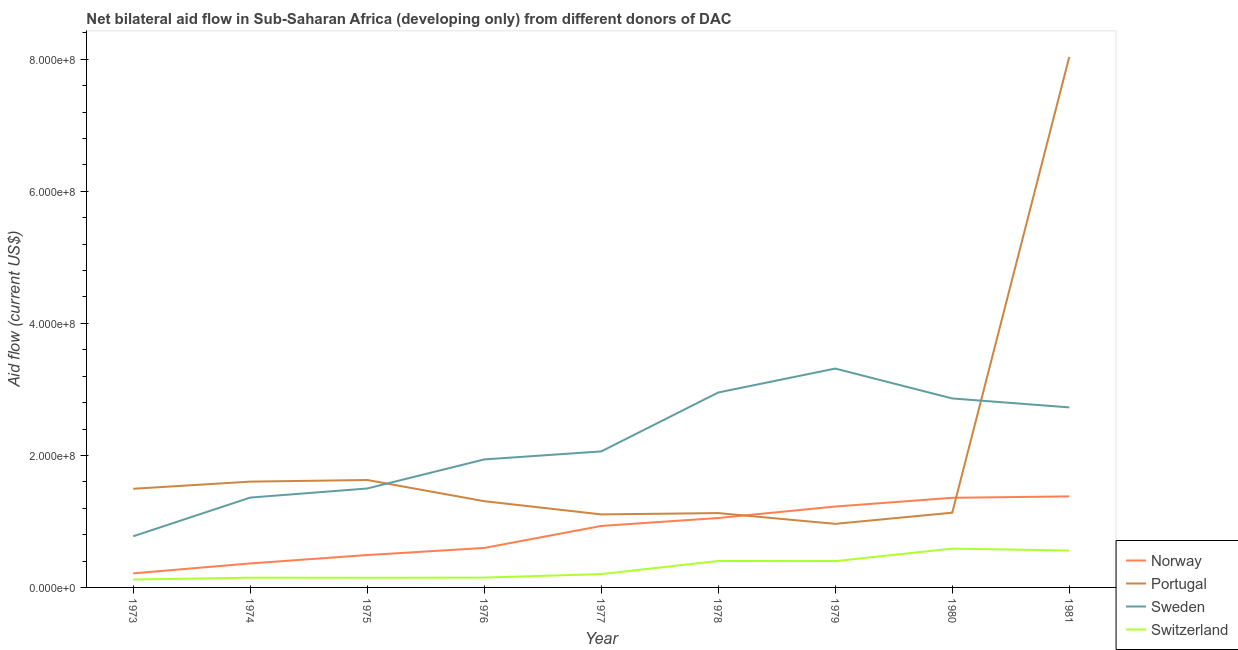Does the line corresponding to amount of aid given by sweden intersect with the line corresponding to amount of aid given by switzerland?
Keep it short and to the point. No. Is the number of lines equal to the number of legend labels?
Provide a short and direct response. Yes. What is the amount of aid given by portugal in 1973?
Provide a short and direct response. 1.49e+08. Across all years, what is the maximum amount of aid given by portugal?
Your answer should be very brief. 8.04e+08. Across all years, what is the minimum amount of aid given by switzerland?
Give a very brief answer. 1.20e+07. In which year was the amount of aid given by sweden maximum?
Make the answer very short. 1979. What is the total amount of aid given by portugal in the graph?
Provide a short and direct response. 1.84e+09. What is the difference between the amount of aid given by norway in 1977 and that in 1981?
Offer a very short reply. -4.48e+07. What is the difference between the amount of aid given by sweden in 1979 and the amount of aid given by switzerland in 1980?
Your answer should be very brief. 2.73e+08. What is the average amount of aid given by portugal per year?
Provide a short and direct response. 2.04e+08. In the year 1977, what is the difference between the amount of aid given by portugal and amount of aid given by norway?
Make the answer very short. 1.75e+07. In how many years, is the amount of aid given by sweden greater than 480000000 US$?
Keep it short and to the point. 0. What is the ratio of the amount of aid given by norway in 1977 to that in 1979?
Your answer should be very brief. 0.76. What is the difference between the highest and the second highest amount of aid given by switzerland?
Keep it short and to the point. 2.96e+06. What is the difference between the highest and the lowest amount of aid given by portugal?
Make the answer very short. 7.07e+08. Is it the case that in every year, the sum of the amount of aid given by portugal and amount of aid given by switzerland is greater than the sum of amount of aid given by norway and amount of aid given by sweden?
Give a very brief answer. No. Does the amount of aid given by norway monotonically increase over the years?
Provide a short and direct response. Yes. How many years are there in the graph?
Your answer should be very brief. 9. Are the values on the major ticks of Y-axis written in scientific E-notation?
Give a very brief answer. Yes. How many legend labels are there?
Your answer should be very brief. 4. What is the title of the graph?
Make the answer very short. Net bilateral aid flow in Sub-Saharan Africa (developing only) from different donors of DAC. What is the label or title of the X-axis?
Your response must be concise. Year. What is the label or title of the Y-axis?
Keep it short and to the point. Aid flow (current US$). What is the Aid flow (current US$) in Norway in 1973?
Your answer should be very brief. 2.13e+07. What is the Aid flow (current US$) in Portugal in 1973?
Provide a succinct answer. 1.49e+08. What is the Aid flow (current US$) in Sweden in 1973?
Offer a very short reply. 7.75e+07. What is the Aid flow (current US$) of Switzerland in 1973?
Provide a succinct answer. 1.20e+07. What is the Aid flow (current US$) of Norway in 1974?
Keep it short and to the point. 3.63e+07. What is the Aid flow (current US$) in Portugal in 1974?
Your answer should be very brief. 1.60e+08. What is the Aid flow (current US$) of Sweden in 1974?
Keep it short and to the point. 1.36e+08. What is the Aid flow (current US$) in Switzerland in 1974?
Your answer should be compact. 1.48e+07. What is the Aid flow (current US$) in Norway in 1975?
Make the answer very short. 4.91e+07. What is the Aid flow (current US$) of Portugal in 1975?
Provide a short and direct response. 1.63e+08. What is the Aid flow (current US$) in Sweden in 1975?
Your answer should be very brief. 1.50e+08. What is the Aid flow (current US$) in Switzerland in 1975?
Your answer should be compact. 1.46e+07. What is the Aid flow (current US$) in Norway in 1976?
Offer a terse response. 5.98e+07. What is the Aid flow (current US$) of Portugal in 1976?
Your answer should be compact. 1.31e+08. What is the Aid flow (current US$) of Sweden in 1976?
Your answer should be compact. 1.94e+08. What is the Aid flow (current US$) of Switzerland in 1976?
Keep it short and to the point. 1.49e+07. What is the Aid flow (current US$) of Norway in 1977?
Provide a short and direct response. 9.32e+07. What is the Aid flow (current US$) of Portugal in 1977?
Your answer should be very brief. 1.11e+08. What is the Aid flow (current US$) in Sweden in 1977?
Provide a short and direct response. 2.06e+08. What is the Aid flow (current US$) of Switzerland in 1977?
Offer a very short reply. 2.02e+07. What is the Aid flow (current US$) in Norway in 1978?
Give a very brief answer. 1.05e+08. What is the Aid flow (current US$) of Portugal in 1978?
Offer a terse response. 1.13e+08. What is the Aid flow (current US$) of Sweden in 1978?
Keep it short and to the point. 2.95e+08. What is the Aid flow (current US$) of Switzerland in 1978?
Your answer should be compact. 4.01e+07. What is the Aid flow (current US$) of Norway in 1979?
Give a very brief answer. 1.23e+08. What is the Aid flow (current US$) in Portugal in 1979?
Keep it short and to the point. 9.63e+07. What is the Aid flow (current US$) in Sweden in 1979?
Provide a succinct answer. 3.32e+08. What is the Aid flow (current US$) of Switzerland in 1979?
Your answer should be very brief. 3.99e+07. What is the Aid flow (current US$) in Norway in 1980?
Offer a very short reply. 1.36e+08. What is the Aid flow (current US$) in Portugal in 1980?
Keep it short and to the point. 1.13e+08. What is the Aid flow (current US$) of Sweden in 1980?
Ensure brevity in your answer.  2.86e+08. What is the Aid flow (current US$) of Switzerland in 1980?
Give a very brief answer. 5.88e+07. What is the Aid flow (current US$) of Norway in 1981?
Ensure brevity in your answer.  1.38e+08. What is the Aid flow (current US$) of Portugal in 1981?
Your answer should be compact. 8.04e+08. What is the Aid flow (current US$) in Sweden in 1981?
Your answer should be very brief. 2.73e+08. What is the Aid flow (current US$) in Switzerland in 1981?
Offer a very short reply. 5.58e+07. Across all years, what is the maximum Aid flow (current US$) of Norway?
Your answer should be compact. 1.38e+08. Across all years, what is the maximum Aid flow (current US$) of Portugal?
Your answer should be compact. 8.04e+08. Across all years, what is the maximum Aid flow (current US$) in Sweden?
Provide a short and direct response. 3.32e+08. Across all years, what is the maximum Aid flow (current US$) in Switzerland?
Your answer should be very brief. 5.88e+07. Across all years, what is the minimum Aid flow (current US$) in Norway?
Ensure brevity in your answer.  2.13e+07. Across all years, what is the minimum Aid flow (current US$) of Portugal?
Ensure brevity in your answer.  9.63e+07. Across all years, what is the minimum Aid flow (current US$) of Sweden?
Your response must be concise. 7.75e+07. Across all years, what is the minimum Aid flow (current US$) of Switzerland?
Your response must be concise. 1.20e+07. What is the total Aid flow (current US$) in Norway in the graph?
Ensure brevity in your answer.  7.61e+08. What is the total Aid flow (current US$) in Portugal in the graph?
Make the answer very short. 1.84e+09. What is the total Aid flow (current US$) in Sweden in the graph?
Provide a short and direct response. 1.95e+09. What is the total Aid flow (current US$) in Switzerland in the graph?
Your answer should be compact. 2.71e+08. What is the difference between the Aid flow (current US$) in Norway in 1973 and that in 1974?
Make the answer very short. -1.50e+07. What is the difference between the Aid flow (current US$) in Portugal in 1973 and that in 1974?
Your response must be concise. -1.08e+07. What is the difference between the Aid flow (current US$) in Sweden in 1973 and that in 1974?
Your response must be concise. -5.86e+07. What is the difference between the Aid flow (current US$) in Switzerland in 1973 and that in 1974?
Provide a short and direct response. -2.82e+06. What is the difference between the Aid flow (current US$) in Norway in 1973 and that in 1975?
Ensure brevity in your answer.  -2.77e+07. What is the difference between the Aid flow (current US$) of Portugal in 1973 and that in 1975?
Your answer should be very brief. -1.33e+07. What is the difference between the Aid flow (current US$) of Sweden in 1973 and that in 1975?
Make the answer very short. -7.24e+07. What is the difference between the Aid flow (current US$) of Switzerland in 1973 and that in 1975?
Offer a very short reply. -2.65e+06. What is the difference between the Aid flow (current US$) in Norway in 1973 and that in 1976?
Ensure brevity in your answer.  -3.85e+07. What is the difference between the Aid flow (current US$) in Portugal in 1973 and that in 1976?
Make the answer very short. 1.88e+07. What is the difference between the Aid flow (current US$) in Sweden in 1973 and that in 1976?
Make the answer very short. -1.16e+08. What is the difference between the Aid flow (current US$) of Switzerland in 1973 and that in 1976?
Give a very brief answer. -2.95e+06. What is the difference between the Aid flow (current US$) of Norway in 1973 and that in 1977?
Make the answer very short. -7.18e+07. What is the difference between the Aid flow (current US$) of Portugal in 1973 and that in 1977?
Your answer should be very brief. 3.88e+07. What is the difference between the Aid flow (current US$) of Sweden in 1973 and that in 1977?
Your response must be concise. -1.29e+08. What is the difference between the Aid flow (current US$) in Switzerland in 1973 and that in 1977?
Give a very brief answer. -8.27e+06. What is the difference between the Aid flow (current US$) in Norway in 1973 and that in 1978?
Your response must be concise. -8.38e+07. What is the difference between the Aid flow (current US$) in Portugal in 1973 and that in 1978?
Ensure brevity in your answer.  3.68e+07. What is the difference between the Aid flow (current US$) in Sweden in 1973 and that in 1978?
Provide a succinct answer. -2.18e+08. What is the difference between the Aid flow (current US$) in Switzerland in 1973 and that in 1978?
Make the answer very short. -2.81e+07. What is the difference between the Aid flow (current US$) of Norway in 1973 and that in 1979?
Your answer should be very brief. -1.01e+08. What is the difference between the Aid flow (current US$) of Portugal in 1973 and that in 1979?
Your response must be concise. 5.31e+07. What is the difference between the Aid flow (current US$) of Sweden in 1973 and that in 1979?
Your answer should be very brief. -2.54e+08. What is the difference between the Aid flow (current US$) of Switzerland in 1973 and that in 1979?
Provide a short and direct response. -2.79e+07. What is the difference between the Aid flow (current US$) of Norway in 1973 and that in 1980?
Keep it short and to the point. -1.14e+08. What is the difference between the Aid flow (current US$) in Portugal in 1973 and that in 1980?
Keep it short and to the point. 3.62e+07. What is the difference between the Aid flow (current US$) of Sweden in 1973 and that in 1980?
Offer a very short reply. -2.09e+08. What is the difference between the Aid flow (current US$) in Switzerland in 1973 and that in 1980?
Your response must be concise. -4.69e+07. What is the difference between the Aid flow (current US$) of Norway in 1973 and that in 1981?
Provide a short and direct response. -1.17e+08. What is the difference between the Aid flow (current US$) in Portugal in 1973 and that in 1981?
Provide a succinct answer. -6.54e+08. What is the difference between the Aid flow (current US$) of Sweden in 1973 and that in 1981?
Give a very brief answer. -1.95e+08. What is the difference between the Aid flow (current US$) of Switzerland in 1973 and that in 1981?
Your response must be concise. -4.39e+07. What is the difference between the Aid flow (current US$) in Norway in 1974 and that in 1975?
Make the answer very short. -1.27e+07. What is the difference between the Aid flow (current US$) of Portugal in 1974 and that in 1975?
Give a very brief answer. -2.45e+06. What is the difference between the Aid flow (current US$) in Sweden in 1974 and that in 1975?
Your answer should be compact. -1.38e+07. What is the difference between the Aid flow (current US$) in Norway in 1974 and that in 1976?
Provide a succinct answer. -2.35e+07. What is the difference between the Aid flow (current US$) of Portugal in 1974 and that in 1976?
Your answer should be very brief. 2.96e+07. What is the difference between the Aid flow (current US$) in Sweden in 1974 and that in 1976?
Provide a succinct answer. -5.78e+07. What is the difference between the Aid flow (current US$) of Switzerland in 1974 and that in 1976?
Your answer should be compact. -1.30e+05. What is the difference between the Aid flow (current US$) of Norway in 1974 and that in 1977?
Provide a short and direct response. -5.68e+07. What is the difference between the Aid flow (current US$) of Portugal in 1974 and that in 1977?
Offer a terse response. 4.97e+07. What is the difference between the Aid flow (current US$) in Sweden in 1974 and that in 1977?
Ensure brevity in your answer.  -7.00e+07. What is the difference between the Aid flow (current US$) in Switzerland in 1974 and that in 1977?
Provide a short and direct response. -5.45e+06. What is the difference between the Aid flow (current US$) in Norway in 1974 and that in 1978?
Give a very brief answer. -6.88e+07. What is the difference between the Aid flow (current US$) in Portugal in 1974 and that in 1978?
Offer a terse response. 4.77e+07. What is the difference between the Aid flow (current US$) in Sweden in 1974 and that in 1978?
Ensure brevity in your answer.  -1.59e+08. What is the difference between the Aid flow (current US$) in Switzerland in 1974 and that in 1978?
Make the answer very short. -2.53e+07. What is the difference between the Aid flow (current US$) of Norway in 1974 and that in 1979?
Make the answer very short. -8.62e+07. What is the difference between the Aid flow (current US$) in Portugal in 1974 and that in 1979?
Your answer should be compact. 6.40e+07. What is the difference between the Aid flow (current US$) of Sweden in 1974 and that in 1979?
Give a very brief answer. -1.95e+08. What is the difference between the Aid flow (current US$) of Switzerland in 1974 and that in 1979?
Your answer should be very brief. -2.51e+07. What is the difference between the Aid flow (current US$) of Norway in 1974 and that in 1980?
Provide a short and direct response. -9.94e+07. What is the difference between the Aid flow (current US$) in Portugal in 1974 and that in 1980?
Ensure brevity in your answer.  4.71e+07. What is the difference between the Aid flow (current US$) in Sweden in 1974 and that in 1980?
Offer a terse response. -1.50e+08. What is the difference between the Aid flow (current US$) of Switzerland in 1974 and that in 1980?
Provide a succinct answer. -4.40e+07. What is the difference between the Aid flow (current US$) in Norway in 1974 and that in 1981?
Offer a terse response. -1.02e+08. What is the difference between the Aid flow (current US$) of Portugal in 1974 and that in 1981?
Ensure brevity in your answer.  -6.43e+08. What is the difference between the Aid flow (current US$) of Sweden in 1974 and that in 1981?
Your response must be concise. -1.37e+08. What is the difference between the Aid flow (current US$) in Switzerland in 1974 and that in 1981?
Provide a succinct answer. -4.11e+07. What is the difference between the Aid flow (current US$) in Norway in 1975 and that in 1976?
Your answer should be very brief. -1.07e+07. What is the difference between the Aid flow (current US$) in Portugal in 1975 and that in 1976?
Offer a very short reply. 3.21e+07. What is the difference between the Aid flow (current US$) of Sweden in 1975 and that in 1976?
Keep it short and to the point. -4.40e+07. What is the difference between the Aid flow (current US$) of Switzerland in 1975 and that in 1976?
Your answer should be very brief. -3.00e+05. What is the difference between the Aid flow (current US$) of Norway in 1975 and that in 1977?
Provide a short and direct response. -4.41e+07. What is the difference between the Aid flow (current US$) in Portugal in 1975 and that in 1977?
Make the answer very short. 5.21e+07. What is the difference between the Aid flow (current US$) of Sweden in 1975 and that in 1977?
Your response must be concise. -5.62e+07. What is the difference between the Aid flow (current US$) of Switzerland in 1975 and that in 1977?
Offer a very short reply. -5.62e+06. What is the difference between the Aid flow (current US$) in Norway in 1975 and that in 1978?
Provide a succinct answer. -5.61e+07. What is the difference between the Aid flow (current US$) in Portugal in 1975 and that in 1978?
Make the answer very short. 5.01e+07. What is the difference between the Aid flow (current US$) of Sweden in 1975 and that in 1978?
Ensure brevity in your answer.  -1.45e+08. What is the difference between the Aid flow (current US$) in Switzerland in 1975 and that in 1978?
Provide a succinct answer. -2.55e+07. What is the difference between the Aid flow (current US$) of Norway in 1975 and that in 1979?
Your answer should be very brief. -7.35e+07. What is the difference between the Aid flow (current US$) in Portugal in 1975 and that in 1979?
Offer a terse response. 6.64e+07. What is the difference between the Aid flow (current US$) of Sweden in 1975 and that in 1979?
Your answer should be very brief. -1.82e+08. What is the difference between the Aid flow (current US$) in Switzerland in 1975 and that in 1979?
Ensure brevity in your answer.  -2.53e+07. What is the difference between the Aid flow (current US$) in Norway in 1975 and that in 1980?
Your answer should be very brief. -8.67e+07. What is the difference between the Aid flow (current US$) in Portugal in 1975 and that in 1980?
Ensure brevity in your answer.  4.95e+07. What is the difference between the Aid flow (current US$) of Sweden in 1975 and that in 1980?
Provide a succinct answer. -1.36e+08. What is the difference between the Aid flow (current US$) in Switzerland in 1975 and that in 1980?
Make the answer very short. -4.42e+07. What is the difference between the Aid flow (current US$) of Norway in 1975 and that in 1981?
Your answer should be very brief. -8.89e+07. What is the difference between the Aid flow (current US$) in Portugal in 1975 and that in 1981?
Provide a succinct answer. -6.41e+08. What is the difference between the Aid flow (current US$) of Sweden in 1975 and that in 1981?
Ensure brevity in your answer.  -1.23e+08. What is the difference between the Aid flow (current US$) in Switzerland in 1975 and that in 1981?
Your answer should be compact. -4.12e+07. What is the difference between the Aid flow (current US$) of Norway in 1976 and that in 1977?
Give a very brief answer. -3.34e+07. What is the difference between the Aid flow (current US$) in Portugal in 1976 and that in 1977?
Offer a terse response. 2.00e+07. What is the difference between the Aid flow (current US$) in Sweden in 1976 and that in 1977?
Ensure brevity in your answer.  -1.22e+07. What is the difference between the Aid flow (current US$) in Switzerland in 1976 and that in 1977?
Offer a terse response. -5.32e+06. What is the difference between the Aid flow (current US$) in Norway in 1976 and that in 1978?
Your answer should be compact. -4.54e+07. What is the difference between the Aid flow (current US$) in Portugal in 1976 and that in 1978?
Ensure brevity in your answer.  1.80e+07. What is the difference between the Aid flow (current US$) of Sweden in 1976 and that in 1978?
Offer a terse response. -1.01e+08. What is the difference between the Aid flow (current US$) in Switzerland in 1976 and that in 1978?
Provide a succinct answer. -2.52e+07. What is the difference between the Aid flow (current US$) of Norway in 1976 and that in 1979?
Provide a short and direct response. -6.27e+07. What is the difference between the Aid flow (current US$) of Portugal in 1976 and that in 1979?
Give a very brief answer. 3.43e+07. What is the difference between the Aid flow (current US$) in Sweden in 1976 and that in 1979?
Provide a succinct answer. -1.38e+08. What is the difference between the Aid flow (current US$) in Switzerland in 1976 and that in 1979?
Make the answer very short. -2.50e+07. What is the difference between the Aid flow (current US$) in Norway in 1976 and that in 1980?
Ensure brevity in your answer.  -7.60e+07. What is the difference between the Aid flow (current US$) of Portugal in 1976 and that in 1980?
Ensure brevity in your answer.  1.74e+07. What is the difference between the Aid flow (current US$) of Sweden in 1976 and that in 1980?
Offer a terse response. -9.24e+07. What is the difference between the Aid flow (current US$) of Switzerland in 1976 and that in 1980?
Make the answer very short. -4.39e+07. What is the difference between the Aid flow (current US$) in Norway in 1976 and that in 1981?
Provide a succinct answer. -7.81e+07. What is the difference between the Aid flow (current US$) of Portugal in 1976 and that in 1981?
Offer a terse response. -6.73e+08. What is the difference between the Aid flow (current US$) of Sweden in 1976 and that in 1981?
Keep it short and to the point. -7.88e+07. What is the difference between the Aid flow (current US$) of Switzerland in 1976 and that in 1981?
Provide a short and direct response. -4.10e+07. What is the difference between the Aid flow (current US$) in Norway in 1977 and that in 1978?
Your answer should be compact. -1.20e+07. What is the difference between the Aid flow (current US$) in Portugal in 1977 and that in 1978?
Your answer should be compact. -2.00e+06. What is the difference between the Aid flow (current US$) in Sweden in 1977 and that in 1978?
Your answer should be very brief. -8.92e+07. What is the difference between the Aid flow (current US$) of Switzerland in 1977 and that in 1978?
Provide a short and direct response. -1.98e+07. What is the difference between the Aid flow (current US$) in Norway in 1977 and that in 1979?
Offer a very short reply. -2.94e+07. What is the difference between the Aid flow (current US$) of Portugal in 1977 and that in 1979?
Make the answer very short. 1.43e+07. What is the difference between the Aid flow (current US$) in Sweden in 1977 and that in 1979?
Your answer should be compact. -1.26e+08. What is the difference between the Aid flow (current US$) in Switzerland in 1977 and that in 1979?
Provide a short and direct response. -1.97e+07. What is the difference between the Aid flow (current US$) of Norway in 1977 and that in 1980?
Your answer should be very brief. -4.26e+07. What is the difference between the Aid flow (current US$) in Portugal in 1977 and that in 1980?
Make the answer very short. -2.60e+06. What is the difference between the Aid flow (current US$) of Sweden in 1977 and that in 1980?
Give a very brief answer. -8.02e+07. What is the difference between the Aid flow (current US$) in Switzerland in 1977 and that in 1980?
Provide a short and direct response. -3.86e+07. What is the difference between the Aid flow (current US$) of Norway in 1977 and that in 1981?
Make the answer very short. -4.48e+07. What is the difference between the Aid flow (current US$) of Portugal in 1977 and that in 1981?
Keep it short and to the point. -6.93e+08. What is the difference between the Aid flow (current US$) in Sweden in 1977 and that in 1981?
Make the answer very short. -6.67e+07. What is the difference between the Aid flow (current US$) of Switzerland in 1977 and that in 1981?
Provide a succinct answer. -3.56e+07. What is the difference between the Aid flow (current US$) of Norway in 1978 and that in 1979?
Offer a terse response. -1.74e+07. What is the difference between the Aid flow (current US$) of Portugal in 1978 and that in 1979?
Give a very brief answer. 1.63e+07. What is the difference between the Aid flow (current US$) in Sweden in 1978 and that in 1979?
Keep it short and to the point. -3.62e+07. What is the difference between the Aid flow (current US$) of Switzerland in 1978 and that in 1979?
Provide a succinct answer. 1.90e+05. What is the difference between the Aid flow (current US$) of Norway in 1978 and that in 1980?
Make the answer very short. -3.06e+07. What is the difference between the Aid flow (current US$) in Portugal in 1978 and that in 1980?
Your answer should be compact. -6.00e+05. What is the difference between the Aid flow (current US$) of Sweden in 1978 and that in 1980?
Give a very brief answer. 9.03e+06. What is the difference between the Aid flow (current US$) of Switzerland in 1978 and that in 1980?
Your response must be concise. -1.87e+07. What is the difference between the Aid flow (current US$) of Norway in 1978 and that in 1981?
Ensure brevity in your answer.  -3.28e+07. What is the difference between the Aid flow (current US$) of Portugal in 1978 and that in 1981?
Give a very brief answer. -6.91e+08. What is the difference between the Aid flow (current US$) of Sweden in 1978 and that in 1981?
Your answer should be compact. 2.26e+07. What is the difference between the Aid flow (current US$) in Switzerland in 1978 and that in 1981?
Provide a short and direct response. -1.58e+07. What is the difference between the Aid flow (current US$) of Norway in 1979 and that in 1980?
Offer a very short reply. -1.32e+07. What is the difference between the Aid flow (current US$) of Portugal in 1979 and that in 1980?
Keep it short and to the point. -1.69e+07. What is the difference between the Aid flow (current US$) of Sweden in 1979 and that in 1980?
Your response must be concise. 4.53e+07. What is the difference between the Aid flow (current US$) in Switzerland in 1979 and that in 1980?
Offer a very short reply. -1.89e+07. What is the difference between the Aid flow (current US$) of Norway in 1979 and that in 1981?
Provide a short and direct response. -1.54e+07. What is the difference between the Aid flow (current US$) in Portugal in 1979 and that in 1981?
Your answer should be compact. -7.07e+08. What is the difference between the Aid flow (current US$) in Sweden in 1979 and that in 1981?
Offer a very short reply. 5.88e+07. What is the difference between the Aid flow (current US$) in Switzerland in 1979 and that in 1981?
Provide a succinct answer. -1.60e+07. What is the difference between the Aid flow (current US$) of Norway in 1980 and that in 1981?
Keep it short and to the point. -2.14e+06. What is the difference between the Aid flow (current US$) in Portugal in 1980 and that in 1981?
Offer a terse response. -6.90e+08. What is the difference between the Aid flow (current US$) in Sweden in 1980 and that in 1981?
Make the answer very short. 1.35e+07. What is the difference between the Aid flow (current US$) in Switzerland in 1980 and that in 1981?
Your answer should be very brief. 2.96e+06. What is the difference between the Aid flow (current US$) of Norway in 1973 and the Aid flow (current US$) of Portugal in 1974?
Provide a succinct answer. -1.39e+08. What is the difference between the Aid flow (current US$) of Norway in 1973 and the Aid flow (current US$) of Sweden in 1974?
Your answer should be very brief. -1.15e+08. What is the difference between the Aid flow (current US$) in Norway in 1973 and the Aid flow (current US$) in Switzerland in 1974?
Offer a terse response. 6.55e+06. What is the difference between the Aid flow (current US$) of Portugal in 1973 and the Aid flow (current US$) of Sweden in 1974?
Provide a short and direct response. 1.34e+07. What is the difference between the Aid flow (current US$) of Portugal in 1973 and the Aid flow (current US$) of Switzerland in 1974?
Give a very brief answer. 1.35e+08. What is the difference between the Aid flow (current US$) in Sweden in 1973 and the Aid flow (current US$) in Switzerland in 1974?
Keep it short and to the point. 6.27e+07. What is the difference between the Aid flow (current US$) of Norway in 1973 and the Aid flow (current US$) of Portugal in 1975?
Provide a succinct answer. -1.41e+08. What is the difference between the Aid flow (current US$) in Norway in 1973 and the Aid flow (current US$) in Sweden in 1975?
Keep it short and to the point. -1.29e+08. What is the difference between the Aid flow (current US$) of Norway in 1973 and the Aid flow (current US$) of Switzerland in 1975?
Give a very brief answer. 6.72e+06. What is the difference between the Aid flow (current US$) in Portugal in 1973 and the Aid flow (current US$) in Sweden in 1975?
Your answer should be very brief. -4.30e+05. What is the difference between the Aid flow (current US$) in Portugal in 1973 and the Aid flow (current US$) in Switzerland in 1975?
Give a very brief answer. 1.35e+08. What is the difference between the Aid flow (current US$) in Sweden in 1973 and the Aid flow (current US$) in Switzerland in 1975?
Offer a very short reply. 6.29e+07. What is the difference between the Aid flow (current US$) of Norway in 1973 and the Aid flow (current US$) of Portugal in 1976?
Keep it short and to the point. -1.09e+08. What is the difference between the Aid flow (current US$) of Norway in 1973 and the Aid flow (current US$) of Sweden in 1976?
Make the answer very short. -1.73e+08. What is the difference between the Aid flow (current US$) of Norway in 1973 and the Aid flow (current US$) of Switzerland in 1976?
Offer a very short reply. 6.42e+06. What is the difference between the Aid flow (current US$) of Portugal in 1973 and the Aid flow (current US$) of Sweden in 1976?
Make the answer very short. -4.45e+07. What is the difference between the Aid flow (current US$) in Portugal in 1973 and the Aid flow (current US$) in Switzerland in 1976?
Offer a terse response. 1.35e+08. What is the difference between the Aid flow (current US$) of Sweden in 1973 and the Aid flow (current US$) of Switzerland in 1976?
Your answer should be compact. 6.26e+07. What is the difference between the Aid flow (current US$) in Norway in 1973 and the Aid flow (current US$) in Portugal in 1977?
Your answer should be very brief. -8.93e+07. What is the difference between the Aid flow (current US$) in Norway in 1973 and the Aid flow (current US$) in Sweden in 1977?
Ensure brevity in your answer.  -1.85e+08. What is the difference between the Aid flow (current US$) in Norway in 1973 and the Aid flow (current US$) in Switzerland in 1977?
Provide a short and direct response. 1.10e+06. What is the difference between the Aid flow (current US$) of Portugal in 1973 and the Aid flow (current US$) of Sweden in 1977?
Make the answer very short. -5.66e+07. What is the difference between the Aid flow (current US$) of Portugal in 1973 and the Aid flow (current US$) of Switzerland in 1977?
Your response must be concise. 1.29e+08. What is the difference between the Aid flow (current US$) of Sweden in 1973 and the Aid flow (current US$) of Switzerland in 1977?
Your response must be concise. 5.73e+07. What is the difference between the Aid flow (current US$) in Norway in 1973 and the Aid flow (current US$) in Portugal in 1978?
Your answer should be very brief. -9.13e+07. What is the difference between the Aid flow (current US$) of Norway in 1973 and the Aid flow (current US$) of Sweden in 1978?
Offer a very short reply. -2.74e+08. What is the difference between the Aid flow (current US$) in Norway in 1973 and the Aid flow (current US$) in Switzerland in 1978?
Keep it short and to the point. -1.88e+07. What is the difference between the Aid flow (current US$) in Portugal in 1973 and the Aid flow (current US$) in Sweden in 1978?
Your response must be concise. -1.46e+08. What is the difference between the Aid flow (current US$) in Portugal in 1973 and the Aid flow (current US$) in Switzerland in 1978?
Your answer should be very brief. 1.09e+08. What is the difference between the Aid flow (current US$) of Sweden in 1973 and the Aid flow (current US$) of Switzerland in 1978?
Keep it short and to the point. 3.74e+07. What is the difference between the Aid flow (current US$) of Norway in 1973 and the Aid flow (current US$) of Portugal in 1979?
Give a very brief answer. -7.50e+07. What is the difference between the Aid flow (current US$) of Norway in 1973 and the Aid flow (current US$) of Sweden in 1979?
Offer a very short reply. -3.10e+08. What is the difference between the Aid flow (current US$) of Norway in 1973 and the Aid flow (current US$) of Switzerland in 1979?
Keep it short and to the point. -1.86e+07. What is the difference between the Aid flow (current US$) in Portugal in 1973 and the Aid flow (current US$) in Sweden in 1979?
Offer a very short reply. -1.82e+08. What is the difference between the Aid flow (current US$) in Portugal in 1973 and the Aid flow (current US$) in Switzerland in 1979?
Ensure brevity in your answer.  1.10e+08. What is the difference between the Aid flow (current US$) in Sweden in 1973 and the Aid flow (current US$) in Switzerland in 1979?
Offer a terse response. 3.76e+07. What is the difference between the Aid flow (current US$) in Norway in 1973 and the Aid flow (current US$) in Portugal in 1980?
Offer a terse response. -9.19e+07. What is the difference between the Aid flow (current US$) in Norway in 1973 and the Aid flow (current US$) in Sweden in 1980?
Your answer should be compact. -2.65e+08. What is the difference between the Aid flow (current US$) of Norway in 1973 and the Aid flow (current US$) of Switzerland in 1980?
Ensure brevity in your answer.  -3.75e+07. What is the difference between the Aid flow (current US$) of Portugal in 1973 and the Aid flow (current US$) of Sweden in 1980?
Offer a terse response. -1.37e+08. What is the difference between the Aid flow (current US$) in Portugal in 1973 and the Aid flow (current US$) in Switzerland in 1980?
Keep it short and to the point. 9.06e+07. What is the difference between the Aid flow (current US$) in Sweden in 1973 and the Aid flow (current US$) in Switzerland in 1980?
Offer a very short reply. 1.87e+07. What is the difference between the Aid flow (current US$) of Norway in 1973 and the Aid flow (current US$) of Portugal in 1981?
Your answer should be very brief. -7.82e+08. What is the difference between the Aid flow (current US$) in Norway in 1973 and the Aid flow (current US$) in Sweden in 1981?
Ensure brevity in your answer.  -2.51e+08. What is the difference between the Aid flow (current US$) in Norway in 1973 and the Aid flow (current US$) in Switzerland in 1981?
Keep it short and to the point. -3.45e+07. What is the difference between the Aid flow (current US$) in Portugal in 1973 and the Aid flow (current US$) in Sweden in 1981?
Your answer should be compact. -1.23e+08. What is the difference between the Aid flow (current US$) of Portugal in 1973 and the Aid flow (current US$) of Switzerland in 1981?
Keep it short and to the point. 9.36e+07. What is the difference between the Aid flow (current US$) in Sweden in 1973 and the Aid flow (current US$) in Switzerland in 1981?
Make the answer very short. 2.16e+07. What is the difference between the Aid flow (current US$) of Norway in 1974 and the Aid flow (current US$) of Portugal in 1975?
Give a very brief answer. -1.26e+08. What is the difference between the Aid flow (current US$) in Norway in 1974 and the Aid flow (current US$) in Sweden in 1975?
Offer a terse response. -1.14e+08. What is the difference between the Aid flow (current US$) of Norway in 1974 and the Aid flow (current US$) of Switzerland in 1975?
Offer a terse response. 2.17e+07. What is the difference between the Aid flow (current US$) in Portugal in 1974 and the Aid flow (current US$) in Sweden in 1975?
Make the answer very short. 1.04e+07. What is the difference between the Aid flow (current US$) of Portugal in 1974 and the Aid flow (current US$) of Switzerland in 1975?
Your answer should be very brief. 1.46e+08. What is the difference between the Aid flow (current US$) in Sweden in 1974 and the Aid flow (current US$) in Switzerland in 1975?
Your answer should be very brief. 1.22e+08. What is the difference between the Aid flow (current US$) in Norway in 1974 and the Aid flow (current US$) in Portugal in 1976?
Keep it short and to the point. -9.43e+07. What is the difference between the Aid flow (current US$) of Norway in 1974 and the Aid flow (current US$) of Sweden in 1976?
Your answer should be compact. -1.58e+08. What is the difference between the Aid flow (current US$) of Norway in 1974 and the Aid flow (current US$) of Switzerland in 1976?
Make the answer very short. 2.14e+07. What is the difference between the Aid flow (current US$) in Portugal in 1974 and the Aid flow (current US$) in Sweden in 1976?
Your answer should be compact. -3.36e+07. What is the difference between the Aid flow (current US$) of Portugal in 1974 and the Aid flow (current US$) of Switzerland in 1976?
Your answer should be compact. 1.45e+08. What is the difference between the Aid flow (current US$) of Sweden in 1974 and the Aid flow (current US$) of Switzerland in 1976?
Ensure brevity in your answer.  1.21e+08. What is the difference between the Aid flow (current US$) of Norway in 1974 and the Aid flow (current US$) of Portugal in 1977?
Make the answer very short. -7.43e+07. What is the difference between the Aid flow (current US$) of Norway in 1974 and the Aid flow (current US$) of Sweden in 1977?
Give a very brief answer. -1.70e+08. What is the difference between the Aid flow (current US$) of Norway in 1974 and the Aid flow (current US$) of Switzerland in 1977?
Your answer should be compact. 1.61e+07. What is the difference between the Aid flow (current US$) in Portugal in 1974 and the Aid flow (current US$) in Sweden in 1977?
Provide a short and direct response. -4.58e+07. What is the difference between the Aid flow (current US$) in Portugal in 1974 and the Aid flow (current US$) in Switzerland in 1977?
Provide a short and direct response. 1.40e+08. What is the difference between the Aid flow (current US$) in Sweden in 1974 and the Aid flow (current US$) in Switzerland in 1977?
Provide a succinct answer. 1.16e+08. What is the difference between the Aid flow (current US$) of Norway in 1974 and the Aid flow (current US$) of Portugal in 1978?
Keep it short and to the point. -7.63e+07. What is the difference between the Aid flow (current US$) of Norway in 1974 and the Aid flow (current US$) of Sweden in 1978?
Provide a succinct answer. -2.59e+08. What is the difference between the Aid flow (current US$) in Norway in 1974 and the Aid flow (current US$) in Switzerland in 1978?
Make the answer very short. -3.73e+06. What is the difference between the Aid flow (current US$) of Portugal in 1974 and the Aid flow (current US$) of Sweden in 1978?
Give a very brief answer. -1.35e+08. What is the difference between the Aid flow (current US$) of Portugal in 1974 and the Aid flow (current US$) of Switzerland in 1978?
Keep it short and to the point. 1.20e+08. What is the difference between the Aid flow (current US$) of Sweden in 1974 and the Aid flow (current US$) of Switzerland in 1978?
Keep it short and to the point. 9.60e+07. What is the difference between the Aid flow (current US$) of Norway in 1974 and the Aid flow (current US$) of Portugal in 1979?
Offer a very short reply. -6.00e+07. What is the difference between the Aid flow (current US$) in Norway in 1974 and the Aid flow (current US$) in Sweden in 1979?
Your answer should be compact. -2.95e+08. What is the difference between the Aid flow (current US$) in Norway in 1974 and the Aid flow (current US$) in Switzerland in 1979?
Offer a terse response. -3.54e+06. What is the difference between the Aid flow (current US$) of Portugal in 1974 and the Aid flow (current US$) of Sweden in 1979?
Provide a short and direct response. -1.71e+08. What is the difference between the Aid flow (current US$) of Portugal in 1974 and the Aid flow (current US$) of Switzerland in 1979?
Give a very brief answer. 1.20e+08. What is the difference between the Aid flow (current US$) in Sweden in 1974 and the Aid flow (current US$) in Switzerland in 1979?
Your answer should be very brief. 9.62e+07. What is the difference between the Aid flow (current US$) of Norway in 1974 and the Aid flow (current US$) of Portugal in 1980?
Make the answer very short. -7.69e+07. What is the difference between the Aid flow (current US$) in Norway in 1974 and the Aid flow (current US$) in Sweden in 1980?
Your answer should be compact. -2.50e+08. What is the difference between the Aid flow (current US$) in Norway in 1974 and the Aid flow (current US$) in Switzerland in 1980?
Offer a terse response. -2.25e+07. What is the difference between the Aid flow (current US$) of Portugal in 1974 and the Aid flow (current US$) of Sweden in 1980?
Offer a very short reply. -1.26e+08. What is the difference between the Aid flow (current US$) in Portugal in 1974 and the Aid flow (current US$) in Switzerland in 1980?
Offer a very short reply. 1.01e+08. What is the difference between the Aid flow (current US$) of Sweden in 1974 and the Aid flow (current US$) of Switzerland in 1980?
Your answer should be compact. 7.73e+07. What is the difference between the Aid flow (current US$) in Norway in 1974 and the Aid flow (current US$) in Portugal in 1981?
Your answer should be compact. -7.67e+08. What is the difference between the Aid flow (current US$) in Norway in 1974 and the Aid flow (current US$) in Sweden in 1981?
Offer a very short reply. -2.36e+08. What is the difference between the Aid flow (current US$) in Norway in 1974 and the Aid flow (current US$) in Switzerland in 1981?
Give a very brief answer. -1.95e+07. What is the difference between the Aid flow (current US$) of Portugal in 1974 and the Aid flow (current US$) of Sweden in 1981?
Provide a succinct answer. -1.12e+08. What is the difference between the Aid flow (current US$) in Portugal in 1974 and the Aid flow (current US$) in Switzerland in 1981?
Your response must be concise. 1.04e+08. What is the difference between the Aid flow (current US$) of Sweden in 1974 and the Aid flow (current US$) of Switzerland in 1981?
Your answer should be compact. 8.02e+07. What is the difference between the Aid flow (current US$) of Norway in 1975 and the Aid flow (current US$) of Portugal in 1976?
Keep it short and to the point. -8.16e+07. What is the difference between the Aid flow (current US$) of Norway in 1975 and the Aid flow (current US$) of Sweden in 1976?
Give a very brief answer. -1.45e+08. What is the difference between the Aid flow (current US$) of Norway in 1975 and the Aid flow (current US$) of Switzerland in 1976?
Your answer should be compact. 3.42e+07. What is the difference between the Aid flow (current US$) in Portugal in 1975 and the Aid flow (current US$) in Sweden in 1976?
Give a very brief answer. -3.12e+07. What is the difference between the Aid flow (current US$) in Portugal in 1975 and the Aid flow (current US$) in Switzerland in 1976?
Your answer should be compact. 1.48e+08. What is the difference between the Aid flow (current US$) of Sweden in 1975 and the Aid flow (current US$) of Switzerland in 1976?
Ensure brevity in your answer.  1.35e+08. What is the difference between the Aid flow (current US$) of Norway in 1975 and the Aid flow (current US$) of Portugal in 1977?
Your response must be concise. -6.16e+07. What is the difference between the Aid flow (current US$) in Norway in 1975 and the Aid flow (current US$) in Sweden in 1977?
Keep it short and to the point. -1.57e+08. What is the difference between the Aid flow (current US$) in Norway in 1975 and the Aid flow (current US$) in Switzerland in 1977?
Your answer should be very brief. 2.88e+07. What is the difference between the Aid flow (current US$) in Portugal in 1975 and the Aid flow (current US$) in Sweden in 1977?
Keep it short and to the point. -4.33e+07. What is the difference between the Aid flow (current US$) of Portugal in 1975 and the Aid flow (current US$) of Switzerland in 1977?
Your answer should be very brief. 1.43e+08. What is the difference between the Aid flow (current US$) in Sweden in 1975 and the Aid flow (current US$) in Switzerland in 1977?
Provide a short and direct response. 1.30e+08. What is the difference between the Aid flow (current US$) of Norway in 1975 and the Aid flow (current US$) of Portugal in 1978?
Your answer should be compact. -6.36e+07. What is the difference between the Aid flow (current US$) in Norway in 1975 and the Aid flow (current US$) in Sweden in 1978?
Provide a short and direct response. -2.46e+08. What is the difference between the Aid flow (current US$) of Norway in 1975 and the Aid flow (current US$) of Switzerland in 1978?
Your response must be concise. 8.99e+06. What is the difference between the Aid flow (current US$) in Portugal in 1975 and the Aid flow (current US$) in Sweden in 1978?
Your answer should be compact. -1.33e+08. What is the difference between the Aid flow (current US$) of Portugal in 1975 and the Aid flow (current US$) of Switzerland in 1978?
Offer a terse response. 1.23e+08. What is the difference between the Aid flow (current US$) of Sweden in 1975 and the Aid flow (current US$) of Switzerland in 1978?
Give a very brief answer. 1.10e+08. What is the difference between the Aid flow (current US$) in Norway in 1975 and the Aid flow (current US$) in Portugal in 1979?
Give a very brief answer. -4.72e+07. What is the difference between the Aid flow (current US$) in Norway in 1975 and the Aid flow (current US$) in Sweden in 1979?
Your answer should be compact. -2.82e+08. What is the difference between the Aid flow (current US$) of Norway in 1975 and the Aid flow (current US$) of Switzerland in 1979?
Make the answer very short. 9.18e+06. What is the difference between the Aid flow (current US$) of Portugal in 1975 and the Aid flow (current US$) of Sweden in 1979?
Offer a terse response. -1.69e+08. What is the difference between the Aid flow (current US$) of Portugal in 1975 and the Aid flow (current US$) of Switzerland in 1979?
Make the answer very short. 1.23e+08. What is the difference between the Aid flow (current US$) of Sweden in 1975 and the Aid flow (current US$) of Switzerland in 1979?
Ensure brevity in your answer.  1.10e+08. What is the difference between the Aid flow (current US$) in Norway in 1975 and the Aid flow (current US$) in Portugal in 1980?
Your answer should be very brief. -6.42e+07. What is the difference between the Aid flow (current US$) in Norway in 1975 and the Aid flow (current US$) in Sweden in 1980?
Provide a succinct answer. -2.37e+08. What is the difference between the Aid flow (current US$) of Norway in 1975 and the Aid flow (current US$) of Switzerland in 1980?
Give a very brief answer. -9.75e+06. What is the difference between the Aid flow (current US$) of Portugal in 1975 and the Aid flow (current US$) of Sweden in 1980?
Your response must be concise. -1.24e+08. What is the difference between the Aid flow (current US$) in Portugal in 1975 and the Aid flow (current US$) in Switzerland in 1980?
Your answer should be very brief. 1.04e+08. What is the difference between the Aid flow (current US$) of Sweden in 1975 and the Aid flow (current US$) of Switzerland in 1980?
Provide a short and direct response. 9.11e+07. What is the difference between the Aid flow (current US$) in Norway in 1975 and the Aid flow (current US$) in Portugal in 1981?
Your answer should be compact. -7.55e+08. What is the difference between the Aid flow (current US$) in Norway in 1975 and the Aid flow (current US$) in Sweden in 1981?
Ensure brevity in your answer.  -2.24e+08. What is the difference between the Aid flow (current US$) in Norway in 1975 and the Aid flow (current US$) in Switzerland in 1981?
Your answer should be very brief. -6.79e+06. What is the difference between the Aid flow (current US$) in Portugal in 1975 and the Aid flow (current US$) in Sweden in 1981?
Ensure brevity in your answer.  -1.10e+08. What is the difference between the Aid flow (current US$) of Portugal in 1975 and the Aid flow (current US$) of Switzerland in 1981?
Ensure brevity in your answer.  1.07e+08. What is the difference between the Aid flow (current US$) in Sweden in 1975 and the Aid flow (current US$) in Switzerland in 1981?
Offer a terse response. 9.40e+07. What is the difference between the Aid flow (current US$) of Norway in 1976 and the Aid flow (current US$) of Portugal in 1977?
Ensure brevity in your answer.  -5.08e+07. What is the difference between the Aid flow (current US$) of Norway in 1976 and the Aid flow (current US$) of Sweden in 1977?
Provide a succinct answer. -1.46e+08. What is the difference between the Aid flow (current US$) in Norway in 1976 and the Aid flow (current US$) in Switzerland in 1977?
Keep it short and to the point. 3.96e+07. What is the difference between the Aid flow (current US$) of Portugal in 1976 and the Aid flow (current US$) of Sweden in 1977?
Offer a very short reply. -7.54e+07. What is the difference between the Aid flow (current US$) of Portugal in 1976 and the Aid flow (current US$) of Switzerland in 1977?
Make the answer very short. 1.10e+08. What is the difference between the Aid flow (current US$) of Sweden in 1976 and the Aid flow (current US$) of Switzerland in 1977?
Provide a short and direct response. 1.74e+08. What is the difference between the Aid flow (current US$) of Norway in 1976 and the Aid flow (current US$) of Portugal in 1978?
Offer a very short reply. -5.28e+07. What is the difference between the Aid flow (current US$) in Norway in 1976 and the Aid flow (current US$) in Sweden in 1978?
Give a very brief answer. -2.36e+08. What is the difference between the Aid flow (current US$) of Norway in 1976 and the Aid flow (current US$) of Switzerland in 1978?
Provide a short and direct response. 1.97e+07. What is the difference between the Aid flow (current US$) of Portugal in 1976 and the Aid flow (current US$) of Sweden in 1978?
Keep it short and to the point. -1.65e+08. What is the difference between the Aid flow (current US$) in Portugal in 1976 and the Aid flow (current US$) in Switzerland in 1978?
Offer a very short reply. 9.06e+07. What is the difference between the Aid flow (current US$) in Sweden in 1976 and the Aid flow (current US$) in Switzerland in 1978?
Give a very brief answer. 1.54e+08. What is the difference between the Aid flow (current US$) in Norway in 1976 and the Aid flow (current US$) in Portugal in 1979?
Ensure brevity in your answer.  -3.65e+07. What is the difference between the Aid flow (current US$) in Norway in 1976 and the Aid flow (current US$) in Sweden in 1979?
Provide a succinct answer. -2.72e+08. What is the difference between the Aid flow (current US$) of Norway in 1976 and the Aid flow (current US$) of Switzerland in 1979?
Your answer should be very brief. 1.99e+07. What is the difference between the Aid flow (current US$) in Portugal in 1976 and the Aid flow (current US$) in Sweden in 1979?
Ensure brevity in your answer.  -2.01e+08. What is the difference between the Aid flow (current US$) of Portugal in 1976 and the Aid flow (current US$) of Switzerland in 1979?
Your answer should be very brief. 9.08e+07. What is the difference between the Aid flow (current US$) in Sweden in 1976 and the Aid flow (current US$) in Switzerland in 1979?
Give a very brief answer. 1.54e+08. What is the difference between the Aid flow (current US$) of Norway in 1976 and the Aid flow (current US$) of Portugal in 1980?
Make the answer very short. -5.34e+07. What is the difference between the Aid flow (current US$) in Norway in 1976 and the Aid flow (current US$) in Sweden in 1980?
Your answer should be very brief. -2.26e+08. What is the difference between the Aid flow (current US$) of Norway in 1976 and the Aid flow (current US$) of Switzerland in 1980?
Provide a succinct answer. 9.90e+05. What is the difference between the Aid flow (current US$) of Portugal in 1976 and the Aid flow (current US$) of Sweden in 1980?
Provide a succinct answer. -1.56e+08. What is the difference between the Aid flow (current US$) of Portugal in 1976 and the Aid flow (current US$) of Switzerland in 1980?
Offer a terse response. 7.18e+07. What is the difference between the Aid flow (current US$) in Sweden in 1976 and the Aid flow (current US$) in Switzerland in 1980?
Offer a very short reply. 1.35e+08. What is the difference between the Aid flow (current US$) of Norway in 1976 and the Aid flow (current US$) of Portugal in 1981?
Offer a terse response. -7.44e+08. What is the difference between the Aid flow (current US$) in Norway in 1976 and the Aid flow (current US$) in Sweden in 1981?
Ensure brevity in your answer.  -2.13e+08. What is the difference between the Aid flow (current US$) of Norway in 1976 and the Aid flow (current US$) of Switzerland in 1981?
Your answer should be very brief. 3.95e+06. What is the difference between the Aid flow (current US$) in Portugal in 1976 and the Aid flow (current US$) in Sweden in 1981?
Your answer should be very brief. -1.42e+08. What is the difference between the Aid flow (current US$) of Portugal in 1976 and the Aid flow (current US$) of Switzerland in 1981?
Make the answer very short. 7.48e+07. What is the difference between the Aid flow (current US$) in Sweden in 1976 and the Aid flow (current US$) in Switzerland in 1981?
Offer a very short reply. 1.38e+08. What is the difference between the Aid flow (current US$) in Norway in 1977 and the Aid flow (current US$) in Portugal in 1978?
Make the answer very short. -1.95e+07. What is the difference between the Aid flow (current US$) in Norway in 1977 and the Aid flow (current US$) in Sweden in 1978?
Offer a very short reply. -2.02e+08. What is the difference between the Aid flow (current US$) in Norway in 1977 and the Aid flow (current US$) in Switzerland in 1978?
Ensure brevity in your answer.  5.31e+07. What is the difference between the Aid flow (current US$) of Portugal in 1977 and the Aid flow (current US$) of Sweden in 1978?
Offer a terse response. -1.85e+08. What is the difference between the Aid flow (current US$) of Portugal in 1977 and the Aid flow (current US$) of Switzerland in 1978?
Provide a succinct answer. 7.06e+07. What is the difference between the Aid flow (current US$) of Sweden in 1977 and the Aid flow (current US$) of Switzerland in 1978?
Make the answer very short. 1.66e+08. What is the difference between the Aid flow (current US$) in Norway in 1977 and the Aid flow (current US$) in Portugal in 1979?
Your answer should be compact. -3.16e+06. What is the difference between the Aid flow (current US$) in Norway in 1977 and the Aid flow (current US$) in Sweden in 1979?
Your response must be concise. -2.38e+08. What is the difference between the Aid flow (current US$) of Norway in 1977 and the Aid flow (current US$) of Switzerland in 1979?
Make the answer very short. 5.33e+07. What is the difference between the Aid flow (current US$) in Portugal in 1977 and the Aid flow (current US$) in Sweden in 1979?
Your answer should be compact. -2.21e+08. What is the difference between the Aid flow (current US$) of Portugal in 1977 and the Aid flow (current US$) of Switzerland in 1979?
Make the answer very short. 7.07e+07. What is the difference between the Aid flow (current US$) in Sweden in 1977 and the Aid flow (current US$) in Switzerland in 1979?
Your answer should be compact. 1.66e+08. What is the difference between the Aid flow (current US$) in Norway in 1977 and the Aid flow (current US$) in Portugal in 1980?
Your response must be concise. -2.01e+07. What is the difference between the Aid flow (current US$) in Norway in 1977 and the Aid flow (current US$) in Sweden in 1980?
Ensure brevity in your answer.  -1.93e+08. What is the difference between the Aid flow (current US$) in Norway in 1977 and the Aid flow (current US$) in Switzerland in 1980?
Offer a very short reply. 3.43e+07. What is the difference between the Aid flow (current US$) of Portugal in 1977 and the Aid flow (current US$) of Sweden in 1980?
Offer a terse response. -1.76e+08. What is the difference between the Aid flow (current US$) in Portugal in 1977 and the Aid flow (current US$) in Switzerland in 1980?
Provide a succinct answer. 5.18e+07. What is the difference between the Aid flow (current US$) in Sweden in 1977 and the Aid flow (current US$) in Switzerland in 1980?
Provide a succinct answer. 1.47e+08. What is the difference between the Aid flow (current US$) of Norway in 1977 and the Aid flow (current US$) of Portugal in 1981?
Provide a succinct answer. -7.10e+08. What is the difference between the Aid flow (current US$) of Norway in 1977 and the Aid flow (current US$) of Sweden in 1981?
Give a very brief answer. -1.80e+08. What is the difference between the Aid flow (current US$) in Norway in 1977 and the Aid flow (current US$) in Switzerland in 1981?
Keep it short and to the point. 3.73e+07. What is the difference between the Aid flow (current US$) of Portugal in 1977 and the Aid flow (current US$) of Sweden in 1981?
Provide a succinct answer. -1.62e+08. What is the difference between the Aid flow (current US$) in Portugal in 1977 and the Aid flow (current US$) in Switzerland in 1981?
Your answer should be very brief. 5.48e+07. What is the difference between the Aid flow (current US$) of Sweden in 1977 and the Aid flow (current US$) of Switzerland in 1981?
Provide a succinct answer. 1.50e+08. What is the difference between the Aid flow (current US$) of Norway in 1978 and the Aid flow (current US$) of Portugal in 1979?
Make the answer very short. 8.86e+06. What is the difference between the Aid flow (current US$) in Norway in 1978 and the Aid flow (current US$) in Sweden in 1979?
Offer a terse response. -2.26e+08. What is the difference between the Aid flow (current US$) in Norway in 1978 and the Aid flow (current US$) in Switzerland in 1979?
Offer a very short reply. 6.53e+07. What is the difference between the Aid flow (current US$) in Portugal in 1978 and the Aid flow (current US$) in Sweden in 1979?
Provide a succinct answer. -2.19e+08. What is the difference between the Aid flow (current US$) in Portugal in 1978 and the Aid flow (current US$) in Switzerland in 1979?
Your answer should be compact. 7.27e+07. What is the difference between the Aid flow (current US$) of Sweden in 1978 and the Aid flow (current US$) of Switzerland in 1979?
Provide a succinct answer. 2.55e+08. What is the difference between the Aid flow (current US$) in Norway in 1978 and the Aid flow (current US$) in Portugal in 1980?
Your response must be concise. -8.05e+06. What is the difference between the Aid flow (current US$) in Norway in 1978 and the Aid flow (current US$) in Sweden in 1980?
Ensure brevity in your answer.  -1.81e+08. What is the difference between the Aid flow (current US$) in Norway in 1978 and the Aid flow (current US$) in Switzerland in 1980?
Ensure brevity in your answer.  4.64e+07. What is the difference between the Aid flow (current US$) of Portugal in 1978 and the Aid flow (current US$) of Sweden in 1980?
Your answer should be very brief. -1.74e+08. What is the difference between the Aid flow (current US$) in Portugal in 1978 and the Aid flow (current US$) in Switzerland in 1980?
Your response must be concise. 5.38e+07. What is the difference between the Aid flow (current US$) of Sweden in 1978 and the Aid flow (current US$) of Switzerland in 1980?
Give a very brief answer. 2.36e+08. What is the difference between the Aid flow (current US$) in Norway in 1978 and the Aid flow (current US$) in Portugal in 1981?
Your answer should be very brief. -6.98e+08. What is the difference between the Aid flow (current US$) of Norway in 1978 and the Aid flow (current US$) of Sweden in 1981?
Keep it short and to the point. -1.68e+08. What is the difference between the Aid flow (current US$) in Norway in 1978 and the Aid flow (current US$) in Switzerland in 1981?
Offer a terse response. 4.93e+07. What is the difference between the Aid flow (current US$) of Portugal in 1978 and the Aid flow (current US$) of Sweden in 1981?
Offer a very short reply. -1.60e+08. What is the difference between the Aid flow (current US$) in Portugal in 1978 and the Aid flow (current US$) in Switzerland in 1981?
Ensure brevity in your answer.  5.68e+07. What is the difference between the Aid flow (current US$) of Sweden in 1978 and the Aid flow (current US$) of Switzerland in 1981?
Your answer should be very brief. 2.39e+08. What is the difference between the Aid flow (current US$) of Norway in 1979 and the Aid flow (current US$) of Portugal in 1980?
Offer a very short reply. 9.32e+06. What is the difference between the Aid flow (current US$) of Norway in 1979 and the Aid flow (current US$) of Sweden in 1980?
Keep it short and to the point. -1.64e+08. What is the difference between the Aid flow (current US$) of Norway in 1979 and the Aid flow (current US$) of Switzerland in 1980?
Make the answer very short. 6.37e+07. What is the difference between the Aid flow (current US$) in Portugal in 1979 and the Aid flow (current US$) in Sweden in 1980?
Your answer should be compact. -1.90e+08. What is the difference between the Aid flow (current US$) in Portugal in 1979 and the Aid flow (current US$) in Switzerland in 1980?
Make the answer very short. 3.75e+07. What is the difference between the Aid flow (current US$) in Sweden in 1979 and the Aid flow (current US$) in Switzerland in 1980?
Give a very brief answer. 2.73e+08. What is the difference between the Aid flow (current US$) of Norway in 1979 and the Aid flow (current US$) of Portugal in 1981?
Make the answer very short. -6.81e+08. What is the difference between the Aid flow (current US$) of Norway in 1979 and the Aid flow (current US$) of Sweden in 1981?
Keep it short and to the point. -1.50e+08. What is the difference between the Aid flow (current US$) of Norway in 1979 and the Aid flow (current US$) of Switzerland in 1981?
Make the answer very short. 6.67e+07. What is the difference between the Aid flow (current US$) in Portugal in 1979 and the Aid flow (current US$) in Sweden in 1981?
Offer a terse response. -1.76e+08. What is the difference between the Aid flow (current US$) of Portugal in 1979 and the Aid flow (current US$) of Switzerland in 1981?
Give a very brief answer. 4.05e+07. What is the difference between the Aid flow (current US$) of Sweden in 1979 and the Aid flow (current US$) of Switzerland in 1981?
Provide a short and direct response. 2.76e+08. What is the difference between the Aid flow (current US$) of Norway in 1980 and the Aid flow (current US$) of Portugal in 1981?
Your response must be concise. -6.68e+08. What is the difference between the Aid flow (current US$) of Norway in 1980 and the Aid flow (current US$) of Sweden in 1981?
Give a very brief answer. -1.37e+08. What is the difference between the Aid flow (current US$) of Norway in 1980 and the Aid flow (current US$) of Switzerland in 1981?
Offer a terse response. 7.99e+07. What is the difference between the Aid flow (current US$) in Portugal in 1980 and the Aid flow (current US$) in Sweden in 1981?
Provide a short and direct response. -1.60e+08. What is the difference between the Aid flow (current US$) in Portugal in 1980 and the Aid flow (current US$) in Switzerland in 1981?
Offer a terse response. 5.74e+07. What is the difference between the Aid flow (current US$) of Sweden in 1980 and the Aid flow (current US$) of Switzerland in 1981?
Provide a short and direct response. 2.30e+08. What is the average Aid flow (current US$) of Norway per year?
Offer a terse response. 8.46e+07. What is the average Aid flow (current US$) of Portugal per year?
Keep it short and to the point. 2.04e+08. What is the average Aid flow (current US$) of Sweden per year?
Offer a very short reply. 2.17e+08. What is the average Aid flow (current US$) of Switzerland per year?
Keep it short and to the point. 3.01e+07. In the year 1973, what is the difference between the Aid flow (current US$) in Norway and Aid flow (current US$) in Portugal?
Offer a very short reply. -1.28e+08. In the year 1973, what is the difference between the Aid flow (current US$) in Norway and Aid flow (current US$) in Sweden?
Make the answer very short. -5.62e+07. In the year 1973, what is the difference between the Aid flow (current US$) in Norway and Aid flow (current US$) in Switzerland?
Your answer should be very brief. 9.37e+06. In the year 1973, what is the difference between the Aid flow (current US$) in Portugal and Aid flow (current US$) in Sweden?
Offer a terse response. 7.20e+07. In the year 1973, what is the difference between the Aid flow (current US$) in Portugal and Aid flow (current US$) in Switzerland?
Provide a short and direct response. 1.38e+08. In the year 1973, what is the difference between the Aid flow (current US$) of Sweden and Aid flow (current US$) of Switzerland?
Provide a short and direct response. 6.56e+07. In the year 1974, what is the difference between the Aid flow (current US$) in Norway and Aid flow (current US$) in Portugal?
Keep it short and to the point. -1.24e+08. In the year 1974, what is the difference between the Aid flow (current US$) in Norway and Aid flow (current US$) in Sweden?
Make the answer very short. -9.98e+07. In the year 1974, what is the difference between the Aid flow (current US$) in Norway and Aid flow (current US$) in Switzerland?
Provide a short and direct response. 2.16e+07. In the year 1974, what is the difference between the Aid flow (current US$) in Portugal and Aid flow (current US$) in Sweden?
Give a very brief answer. 2.42e+07. In the year 1974, what is the difference between the Aid flow (current US$) in Portugal and Aid flow (current US$) in Switzerland?
Keep it short and to the point. 1.46e+08. In the year 1974, what is the difference between the Aid flow (current US$) of Sweden and Aid flow (current US$) of Switzerland?
Offer a very short reply. 1.21e+08. In the year 1975, what is the difference between the Aid flow (current US$) of Norway and Aid flow (current US$) of Portugal?
Keep it short and to the point. -1.14e+08. In the year 1975, what is the difference between the Aid flow (current US$) of Norway and Aid flow (current US$) of Sweden?
Make the answer very short. -1.01e+08. In the year 1975, what is the difference between the Aid flow (current US$) in Norway and Aid flow (current US$) in Switzerland?
Your answer should be very brief. 3.45e+07. In the year 1975, what is the difference between the Aid flow (current US$) in Portugal and Aid flow (current US$) in Sweden?
Make the answer very short. 1.29e+07. In the year 1975, what is the difference between the Aid flow (current US$) of Portugal and Aid flow (current US$) of Switzerland?
Make the answer very short. 1.48e+08. In the year 1975, what is the difference between the Aid flow (current US$) in Sweden and Aid flow (current US$) in Switzerland?
Ensure brevity in your answer.  1.35e+08. In the year 1976, what is the difference between the Aid flow (current US$) of Norway and Aid flow (current US$) of Portugal?
Ensure brevity in your answer.  -7.08e+07. In the year 1976, what is the difference between the Aid flow (current US$) in Norway and Aid flow (current US$) in Sweden?
Provide a short and direct response. -1.34e+08. In the year 1976, what is the difference between the Aid flow (current US$) of Norway and Aid flow (current US$) of Switzerland?
Your answer should be very brief. 4.49e+07. In the year 1976, what is the difference between the Aid flow (current US$) in Portugal and Aid flow (current US$) in Sweden?
Your answer should be very brief. -6.33e+07. In the year 1976, what is the difference between the Aid flow (current US$) in Portugal and Aid flow (current US$) in Switzerland?
Offer a very short reply. 1.16e+08. In the year 1976, what is the difference between the Aid flow (current US$) in Sweden and Aid flow (current US$) in Switzerland?
Your answer should be compact. 1.79e+08. In the year 1977, what is the difference between the Aid flow (current US$) in Norway and Aid flow (current US$) in Portugal?
Your answer should be compact. -1.75e+07. In the year 1977, what is the difference between the Aid flow (current US$) of Norway and Aid flow (current US$) of Sweden?
Provide a short and direct response. -1.13e+08. In the year 1977, what is the difference between the Aid flow (current US$) of Norway and Aid flow (current US$) of Switzerland?
Give a very brief answer. 7.29e+07. In the year 1977, what is the difference between the Aid flow (current US$) in Portugal and Aid flow (current US$) in Sweden?
Provide a succinct answer. -9.54e+07. In the year 1977, what is the difference between the Aid flow (current US$) of Portugal and Aid flow (current US$) of Switzerland?
Give a very brief answer. 9.04e+07. In the year 1977, what is the difference between the Aid flow (current US$) of Sweden and Aid flow (current US$) of Switzerland?
Make the answer very short. 1.86e+08. In the year 1978, what is the difference between the Aid flow (current US$) of Norway and Aid flow (current US$) of Portugal?
Ensure brevity in your answer.  -7.45e+06. In the year 1978, what is the difference between the Aid flow (current US$) in Norway and Aid flow (current US$) in Sweden?
Your answer should be compact. -1.90e+08. In the year 1978, what is the difference between the Aid flow (current US$) in Norway and Aid flow (current US$) in Switzerland?
Your answer should be very brief. 6.51e+07. In the year 1978, what is the difference between the Aid flow (current US$) in Portugal and Aid flow (current US$) in Sweden?
Your answer should be very brief. -1.83e+08. In the year 1978, what is the difference between the Aid flow (current US$) of Portugal and Aid flow (current US$) of Switzerland?
Provide a short and direct response. 7.26e+07. In the year 1978, what is the difference between the Aid flow (current US$) of Sweden and Aid flow (current US$) of Switzerland?
Ensure brevity in your answer.  2.55e+08. In the year 1979, what is the difference between the Aid flow (current US$) in Norway and Aid flow (current US$) in Portugal?
Offer a very short reply. 2.62e+07. In the year 1979, what is the difference between the Aid flow (current US$) in Norway and Aid flow (current US$) in Sweden?
Provide a short and direct response. -2.09e+08. In the year 1979, what is the difference between the Aid flow (current US$) in Norway and Aid flow (current US$) in Switzerland?
Keep it short and to the point. 8.27e+07. In the year 1979, what is the difference between the Aid flow (current US$) of Portugal and Aid flow (current US$) of Sweden?
Make the answer very short. -2.35e+08. In the year 1979, what is the difference between the Aid flow (current US$) of Portugal and Aid flow (current US$) of Switzerland?
Make the answer very short. 5.64e+07. In the year 1979, what is the difference between the Aid flow (current US$) in Sweden and Aid flow (current US$) in Switzerland?
Ensure brevity in your answer.  2.92e+08. In the year 1980, what is the difference between the Aid flow (current US$) of Norway and Aid flow (current US$) of Portugal?
Give a very brief answer. 2.26e+07. In the year 1980, what is the difference between the Aid flow (current US$) of Norway and Aid flow (current US$) of Sweden?
Your answer should be compact. -1.50e+08. In the year 1980, what is the difference between the Aid flow (current US$) of Norway and Aid flow (current US$) of Switzerland?
Ensure brevity in your answer.  7.70e+07. In the year 1980, what is the difference between the Aid flow (current US$) in Portugal and Aid flow (current US$) in Sweden?
Offer a terse response. -1.73e+08. In the year 1980, what is the difference between the Aid flow (current US$) of Portugal and Aid flow (current US$) of Switzerland?
Give a very brief answer. 5.44e+07. In the year 1980, what is the difference between the Aid flow (current US$) of Sweden and Aid flow (current US$) of Switzerland?
Your answer should be compact. 2.27e+08. In the year 1981, what is the difference between the Aid flow (current US$) of Norway and Aid flow (current US$) of Portugal?
Keep it short and to the point. -6.66e+08. In the year 1981, what is the difference between the Aid flow (current US$) of Norway and Aid flow (current US$) of Sweden?
Ensure brevity in your answer.  -1.35e+08. In the year 1981, what is the difference between the Aid flow (current US$) in Norway and Aid flow (current US$) in Switzerland?
Your answer should be very brief. 8.21e+07. In the year 1981, what is the difference between the Aid flow (current US$) of Portugal and Aid flow (current US$) of Sweden?
Provide a short and direct response. 5.31e+08. In the year 1981, what is the difference between the Aid flow (current US$) in Portugal and Aid flow (current US$) in Switzerland?
Provide a short and direct response. 7.48e+08. In the year 1981, what is the difference between the Aid flow (current US$) of Sweden and Aid flow (current US$) of Switzerland?
Your answer should be very brief. 2.17e+08. What is the ratio of the Aid flow (current US$) of Norway in 1973 to that in 1974?
Make the answer very short. 0.59. What is the ratio of the Aid flow (current US$) in Portugal in 1973 to that in 1974?
Keep it short and to the point. 0.93. What is the ratio of the Aid flow (current US$) in Sweden in 1973 to that in 1974?
Your answer should be compact. 0.57. What is the ratio of the Aid flow (current US$) in Switzerland in 1973 to that in 1974?
Make the answer very short. 0.81. What is the ratio of the Aid flow (current US$) of Norway in 1973 to that in 1975?
Give a very brief answer. 0.43. What is the ratio of the Aid flow (current US$) in Portugal in 1973 to that in 1975?
Offer a very short reply. 0.92. What is the ratio of the Aid flow (current US$) of Sweden in 1973 to that in 1975?
Offer a terse response. 0.52. What is the ratio of the Aid flow (current US$) in Switzerland in 1973 to that in 1975?
Keep it short and to the point. 0.82. What is the ratio of the Aid flow (current US$) in Norway in 1973 to that in 1976?
Offer a terse response. 0.36. What is the ratio of the Aid flow (current US$) of Portugal in 1973 to that in 1976?
Ensure brevity in your answer.  1.14. What is the ratio of the Aid flow (current US$) of Sweden in 1973 to that in 1976?
Give a very brief answer. 0.4. What is the ratio of the Aid flow (current US$) of Switzerland in 1973 to that in 1976?
Give a very brief answer. 0.8. What is the ratio of the Aid flow (current US$) in Norway in 1973 to that in 1977?
Keep it short and to the point. 0.23. What is the ratio of the Aid flow (current US$) of Portugal in 1973 to that in 1977?
Give a very brief answer. 1.35. What is the ratio of the Aid flow (current US$) of Sweden in 1973 to that in 1977?
Offer a very short reply. 0.38. What is the ratio of the Aid flow (current US$) in Switzerland in 1973 to that in 1977?
Your answer should be compact. 0.59. What is the ratio of the Aid flow (current US$) in Norway in 1973 to that in 1978?
Your answer should be very brief. 0.2. What is the ratio of the Aid flow (current US$) of Portugal in 1973 to that in 1978?
Your response must be concise. 1.33. What is the ratio of the Aid flow (current US$) in Sweden in 1973 to that in 1978?
Your answer should be very brief. 0.26. What is the ratio of the Aid flow (current US$) of Switzerland in 1973 to that in 1978?
Your answer should be very brief. 0.3. What is the ratio of the Aid flow (current US$) in Norway in 1973 to that in 1979?
Offer a terse response. 0.17. What is the ratio of the Aid flow (current US$) of Portugal in 1973 to that in 1979?
Keep it short and to the point. 1.55. What is the ratio of the Aid flow (current US$) of Sweden in 1973 to that in 1979?
Offer a terse response. 0.23. What is the ratio of the Aid flow (current US$) of Switzerland in 1973 to that in 1979?
Keep it short and to the point. 0.3. What is the ratio of the Aid flow (current US$) of Norway in 1973 to that in 1980?
Provide a short and direct response. 0.16. What is the ratio of the Aid flow (current US$) of Portugal in 1973 to that in 1980?
Give a very brief answer. 1.32. What is the ratio of the Aid flow (current US$) of Sweden in 1973 to that in 1980?
Make the answer very short. 0.27. What is the ratio of the Aid flow (current US$) in Switzerland in 1973 to that in 1980?
Your answer should be compact. 0.2. What is the ratio of the Aid flow (current US$) in Norway in 1973 to that in 1981?
Your answer should be compact. 0.15. What is the ratio of the Aid flow (current US$) of Portugal in 1973 to that in 1981?
Provide a succinct answer. 0.19. What is the ratio of the Aid flow (current US$) of Sweden in 1973 to that in 1981?
Offer a terse response. 0.28. What is the ratio of the Aid flow (current US$) in Switzerland in 1973 to that in 1981?
Offer a very short reply. 0.21. What is the ratio of the Aid flow (current US$) of Norway in 1974 to that in 1975?
Ensure brevity in your answer.  0.74. What is the ratio of the Aid flow (current US$) in Portugal in 1974 to that in 1975?
Provide a succinct answer. 0.98. What is the ratio of the Aid flow (current US$) of Sweden in 1974 to that in 1975?
Make the answer very short. 0.91. What is the ratio of the Aid flow (current US$) in Switzerland in 1974 to that in 1975?
Provide a short and direct response. 1.01. What is the ratio of the Aid flow (current US$) in Norway in 1974 to that in 1976?
Your answer should be compact. 0.61. What is the ratio of the Aid flow (current US$) in Portugal in 1974 to that in 1976?
Keep it short and to the point. 1.23. What is the ratio of the Aid flow (current US$) of Sweden in 1974 to that in 1976?
Ensure brevity in your answer.  0.7. What is the ratio of the Aid flow (current US$) in Switzerland in 1974 to that in 1976?
Offer a terse response. 0.99. What is the ratio of the Aid flow (current US$) of Norway in 1974 to that in 1977?
Provide a short and direct response. 0.39. What is the ratio of the Aid flow (current US$) in Portugal in 1974 to that in 1977?
Your response must be concise. 1.45. What is the ratio of the Aid flow (current US$) in Sweden in 1974 to that in 1977?
Ensure brevity in your answer.  0.66. What is the ratio of the Aid flow (current US$) in Switzerland in 1974 to that in 1977?
Make the answer very short. 0.73. What is the ratio of the Aid flow (current US$) of Norway in 1974 to that in 1978?
Give a very brief answer. 0.35. What is the ratio of the Aid flow (current US$) in Portugal in 1974 to that in 1978?
Offer a very short reply. 1.42. What is the ratio of the Aid flow (current US$) of Sweden in 1974 to that in 1978?
Your answer should be very brief. 0.46. What is the ratio of the Aid flow (current US$) in Switzerland in 1974 to that in 1978?
Make the answer very short. 0.37. What is the ratio of the Aid flow (current US$) in Norway in 1974 to that in 1979?
Your answer should be very brief. 0.3. What is the ratio of the Aid flow (current US$) in Portugal in 1974 to that in 1979?
Your response must be concise. 1.66. What is the ratio of the Aid flow (current US$) in Sweden in 1974 to that in 1979?
Give a very brief answer. 0.41. What is the ratio of the Aid flow (current US$) in Switzerland in 1974 to that in 1979?
Ensure brevity in your answer.  0.37. What is the ratio of the Aid flow (current US$) in Norway in 1974 to that in 1980?
Provide a short and direct response. 0.27. What is the ratio of the Aid flow (current US$) in Portugal in 1974 to that in 1980?
Your answer should be compact. 1.42. What is the ratio of the Aid flow (current US$) in Sweden in 1974 to that in 1980?
Your answer should be very brief. 0.48. What is the ratio of the Aid flow (current US$) of Switzerland in 1974 to that in 1980?
Offer a very short reply. 0.25. What is the ratio of the Aid flow (current US$) in Norway in 1974 to that in 1981?
Your answer should be very brief. 0.26. What is the ratio of the Aid flow (current US$) in Portugal in 1974 to that in 1981?
Keep it short and to the point. 0.2. What is the ratio of the Aid flow (current US$) of Sweden in 1974 to that in 1981?
Ensure brevity in your answer.  0.5. What is the ratio of the Aid flow (current US$) in Switzerland in 1974 to that in 1981?
Offer a terse response. 0.26. What is the ratio of the Aid flow (current US$) of Norway in 1975 to that in 1976?
Ensure brevity in your answer.  0.82. What is the ratio of the Aid flow (current US$) in Portugal in 1975 to that in 1976?
Provide a short and direct response. 1.25. What is the ratio of the Aid flow (current US$) of Sweden in 1975 to that in 1976?
Make the answer very short. 0.77. What is the ratio of the Aid flow (current US$) of Switzerland in 1975 to that in 1976?
Provide a short and direct response. 0.98. What is the ratio of the Aid flow (current US$) in Norway in 1975 to that in 1977?
Your answer should be very brief. 0.53. What is the ratio of the Aid flow (current US$) in Portugal in 1975 to that in 1977?
Provide a short and direct response. 1.47. What is the ratio of the Aid flow (current US$) of Sweden in 1975 to that in 1977?
Your answer should be compact. 0.73. What is the ratio of the Aid flow (current US$) of Switzerland in 1975 to that in 1977?
Give a very brief answer. 0.72. What is the ratio of the Aid flow (current US$) of Norway in 1975 to that in 1978?
Make the answer very short. 0.47. What is the ratio of the Aid flow (current US$) of Portugal in 1975 to that in 1978?
Give a very brief answer. 1.45. What is the ratio of the Aid flow (current US$) of Sweden in 1975 to that in 1978?
Your answer should be very brief. 0.51. What is the ratio of the Aid flow (current US$) of Switzerland in 1975 to that in 1978?
Keep it short and to the point. 0.36. What is the ratio of the Aid flow (current US$) in Norway in 1975 to that in 1979?
Provide a short and direct response. 0.4. What is the ratio of the Aid flow (current US$) in Portugal in 1975 to that in 1979?
Your answer should be very brief. 1.69. What is the ratio of the Aid flow (current US$) of Sweden in 1975 to that in 1979?
Offer a very short reply. 0.45. What is the ratio of the Aid flow (current US$) in Switzerland in 1975 to that in 1979?
Your answer should be compact. 0.37. What is the ratio of the Aid flow (current US$) in Norway in 1975 to that in 1980?
Provide a short and direct response. 0.36. What is the ratio of the Aid flow (current US$) in Portugal in 1975 to that in 1980?
Ensure brevity in your answer.  1.44. What is the ratio of the Aid flow (current US$) in Sweden in 1975 to that in 1980?
Your answer should be very brief. 0.52. What is the ratio of the Aid flow (current US$) of Switzerland in 1975 to that in 1980?
Ensure brevity in your answer.  0.25. What is the ratio of the Aid flow (current US$) of Norway in 1975 to that in 1981?
Provide a succinct answer. 0.36. What is the ratio of the Aid flow (current US$) of Portugal in 1975 to that in 1981?
Keep it short and to the point. 0.2. What is the ratio of the Aid flow (current US$) in Sweden in 1975 to that in 1981?
Your answer should be compact. 0.55. What is the ratio of the Aid flow (current US$) in Switzerland in 1975 to that in 1981?
Provide a short and direct response. 0.26. What is the ratio of the Aid flow (current US$) in Norway in 1976 to that in 1977?
Give a very brief answer. 0.64. What is the ratio of the Aid flow (current US$) in Portugal in 1976 to that in 1977?
Your answer should be compact. 1.18. What is the ratio of the Aid flow (current US$) in Sweden in 1976 to that in 1977?
Your response must be concise. 0.94. What is the ratio of the Aid flow (current US$) of Switzerland in 1976 to that in 1977?
Provide a short and direct response. 0.74. What is the ratio of the Aid flow (current US$) in Norway in 1976 to that in 1978?
Keep it short and to the point. 0.57. What is the ratio of the Aid flow (current US$) of Portugal in 1976 to that in 1978?
Make the answer very short. 1.16. What is the ratio of the Aid flow (current US$) in Sweden in 1976 to that in 1978?
Offer a terse response. 0.66. What is the ratio of the Aid flow (current US$) of Switzerland in 1976 to that in 1978?
Offer a very short reply. 0.37. What is the ratio of the Aid flow (current US$) in Norway in 1976 to that in 1979?
Ensure brevity in your answer.  0.49. What is the ratio of the Aid flow (current US$) in Portugal in 1976 to that in 1979?
Ensure brevity in your answer.  1.36. What is the ratio of the Aid flow (current US$) of Sweden in 1976 to that in 1979?
Provide a short and direct response. 0.58. What is the ratio of the Aid flow (current US$) of Switzerland in 1976 to that in 1979?
Ensure brevity in your answer.  0.37. What is the ratio of the Aid flow (current US$) of Norway in 1976 to that in 1980?
Provide a succinct answer. 0.44. What is the ratio of the Aid flow (current US$) of Portugal in 1976 to that in 1980?
Your response must be concise. 1.15. What is the ratio of the Aid flow (current US$) of Sweden in 1976 to that in 1980?
Provide a succinct answer. 0.68. What is the ratio of the Aid flow (current US$) of Switzerland in 1976 to that in 1980?
Give a very brief answer. 0.25. What is the ratio of the Aid flow (current US$) of Norway in 1976 to that in 1981?
Your answer should be very brief. 0.43. What is the ratio of the Aid flow (current US$) of Portugal in 1976 to that in 1981?
Ensure brevity in your answer.  0.16. What is the ratio of the Aid flow (current US$) of Sweden in 1976 to that in 1981?
Ensure brevity in your answer.  0.71. What is the ratio of the Aid flow (current US$) in Switzerland in 1976 to that in 1981?
Keep it short and to the point. 0.27. What is the ratio of the Aid flow (current US$) of Norway in 1977 to that in 1978?
Offer a very short reply. 0.89. What is the ratio of the Aid flow (current US$) in Portugal in 1977 to that in 1978?
Your answer should be compact. 0.98. What is the ratio of the Aid flow (current US$) of Sweden in 1977 to that in 1978?
Ensure brevity in your answer.  0.7. What is the ratio of the Aid flow (current US$) of Switzerland in 1977 to that in 1978?
Provide a succinct answer. 0.5. What is the ratio of the Aid flow (current US$) of Norway in 1977 to that in 1979?
Your answer should be very brief. 0.76. What is the ratio of the Aid flow (current US$) of Portugal in 1977 to that in 1979?
Provide a succinct answer. 1.15. What is the ratio of the Aid flow (current US$) in Sweden in 1977 to that in 1979?
Ensure brevity in your answer.  0.62. What is the ratio of the Aid flow (current US$) in Switzerland in 1977 to that in 1979?
Offer a terse response. 0.51. What is the ratio of the Aid flow (current US$) in Norway in 1977 to that in 1980?
Offer a very short reply. 0.69. What is the ratio of the Aid flow (current US$) in Sweden in 1977 to that in 1980?
Ensure brevity in your answer.  0.72. What is the ratio of the Aid flow (current US$) in Switzerland in 1977 to that in 1980?
Offer a terse response. 0.34. What is the ratio of the Aid flow (current US$) of Norway in 1977 to that in 1981?
Your answer should be compact. 0.68. What is the ratio of the Aid flow (current US$) in Portugal in 1977 to that in 1981?
Ensure brevity in your answer.  0.14. What is the ratio of the Aid flow (current US$) in Sweden in 1977 to that in 1981?
Make the answer very short. 0.76. What is the ratio of the Aid flow (current US$) of Switzerland in 1977 to that in 1981?
Provide a succinct answer. 0.36. What is the ratio of the Aid flow (current US$) in Norway in 1978 to that in 1979?
Your answer should be very brief. 0.86. What is the ratio of the Aid flow (current US$) in Portugal in 1978 to that in 1979?
Give a very brief answer. 1.17. What is the ratio of the Aid flow (current US$) in Sweden in 1978 to that in 1979?
Your answer should be very brief. 0.89. What is the ratio of the Aid flow (current US$) of Norway in 1978 to that in 1980?
Provide a short and direct response. 0.77. What is the ratio of the Aid flow (current US$) of Portugal in 1978 to that in 1980?
Your answer should be very brief. 0.99. What is the ratio of the Aid flow (current US$) of Sweden in 1978 to that in 1980?
Ensure brevity in your answer.  1.03. What is the ratio of the Aid flow (current US$) in Switzerland in 1978 to that in 1980?
Your response must be concise. 0.68. What is the ratio of the Aid flow (current US$) in Norway in 1978 to that in 1981?
Your answer should be compact. 0.76. What is the ratio of the Aid flow (current US$) in Portugal in 1978 to that in 1981?
Your response must be concise. 0.14. What is the ratio of the Aid flow (current US$) of Sweden in 1978 to that in 1981?
Ensure brevity in your answer.  1.08. What is the ratio of the Aid flow (current US$) of Switzerland in 1978 to that in 1981?
Your answer should be compact. 0.72. What is the ratio of the Aid flow (current US$) in Norway in 1979 to that in 1980?
Provide a short and direct response. 0.9. What is the ratio of the Aid flow (current US$) of Portugal in 1979 to that in 1980?
Your answer should be very brief. 0.85. What is the ratio of the Aid flow (current US$) in Sweden in 1979 to that in 1980?
Keep it short and to the point. 1.16. What is the ratio of the Aid flow (current US$) in Switzerland in 1979 to that in 1980?
Offer a very short reply. 0.68. What is the ratio of the Aid flow (current US$) in Norway in 1979 to that in 1981?
Give a very brief answer. 0.89. What is the ratio of the Aid flow (current US$) in Portugal in 1979 to that in 1981?
Provide a short and direct response. 0.12. What is the ratio of the Aid flow (current US$) in Sweden in 1979 to that in 1981?
Ensure brevity in your answer.  1.22. What is the ratio of the Aid flow (current US$) of Switzerland in 1979 to that in 1981?
Provide a succinct answer. 0.71. What is the ratio of the Aid flow (current US$) of Norway in 1980 to that in 1981?
Your response must be concise. 0.98. What is the ratio of the Aid flow (current US$) in Portugal in 1980 to that in 1981?
Your answer should be very brief. 0.14. What is the ratio of the Aid flow (current US$) of Sweden in 1980 to that in 1981?
Offer a terse response. 1.05. What is the ratio of the Aid flow (current US$) in Switzerland in 1980 to that in 1981?
Make the answer very short. 1.05. What is the difference between the highest and the second highest Aid flow (current US$) of Norway?
Your answer should be very brief. 2.14e+06. What is the difference between the highest and the second highest Aid flow (current US$) of Portugal?
Give a very brief answer. 6.41e+08. What is the difference between the highest and the second highest Aid flow (current US$) in Sweden?
Offer a terse response. 3.62e+07. What is the difference between the highest and the second highest Aid flow (current US$) of Switzerland?
Your answer should be compact. 2.96e+06. What is the difference between the highest and the lowest Aid flow (current US$) of Norway?
Provide a succinct answer. 1.17e+08. What is the difference between the highest and the lowest Aid flow (current US$) in Portugal?
Provide a short and direct response. 7.07e+08. What is the difference between the highest and the lowest Aid flow (current US$) of Sweden?
Provide a short and direct response. 2.54e+08. What is the difference between the highest and the lowest Aid flow (current US$) of Switzerland?
Give a very brief answer. 4.69e+07. 